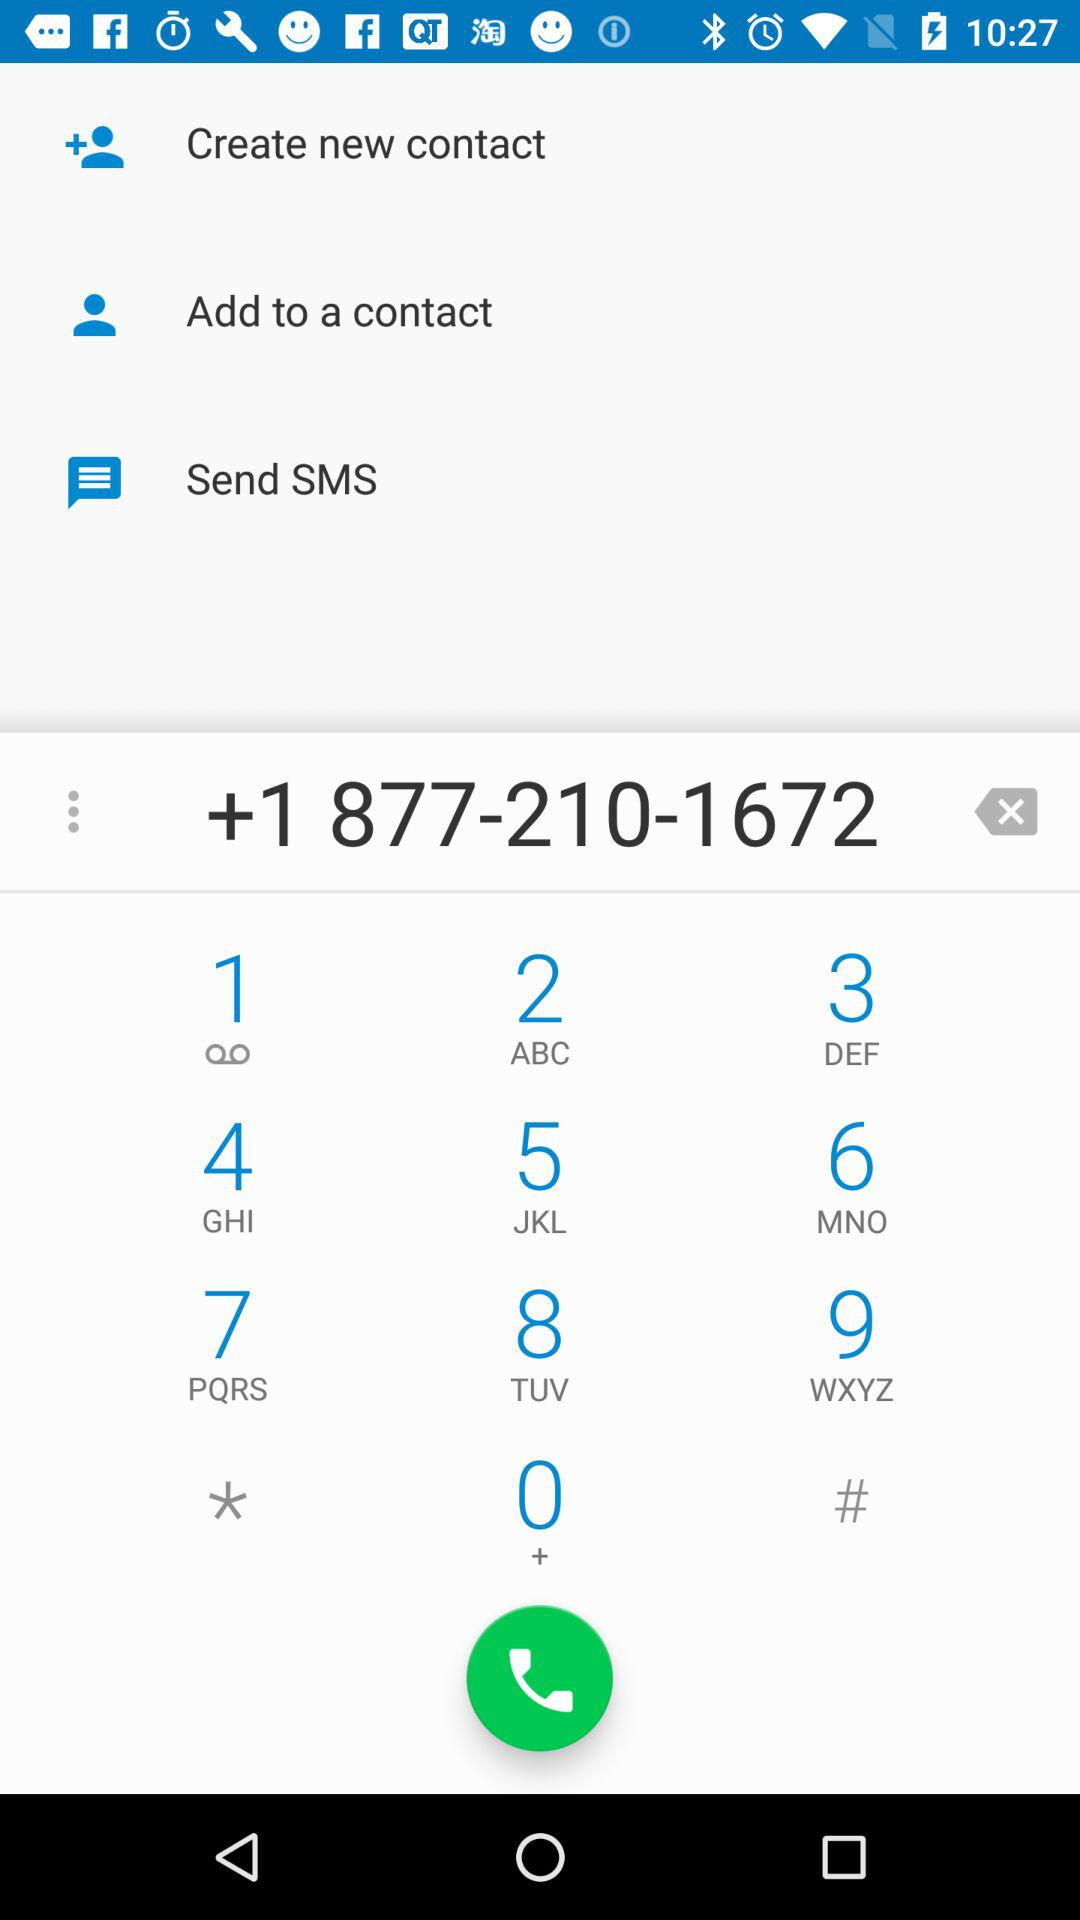How many options are there to add a contact to my phone?
Answer the question using a single word or phrase. 2 